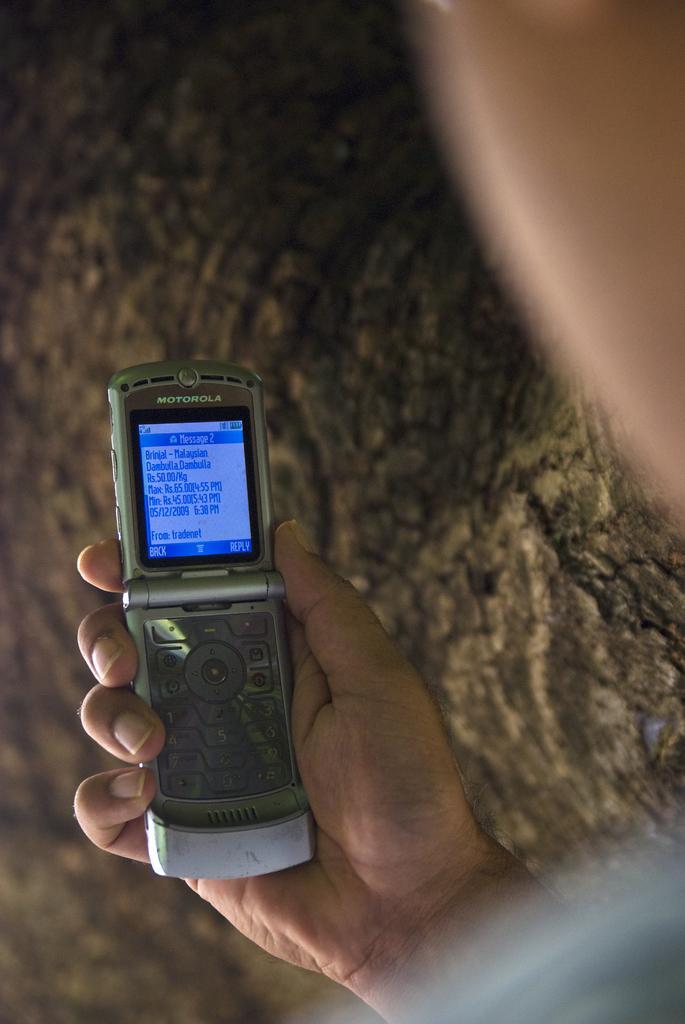Please provide a concise description of this image. In the background there is a tree. On the right side of the image there is a man and he is holding a mobile phone in his hand. There is a text on the mobile phone screen. 